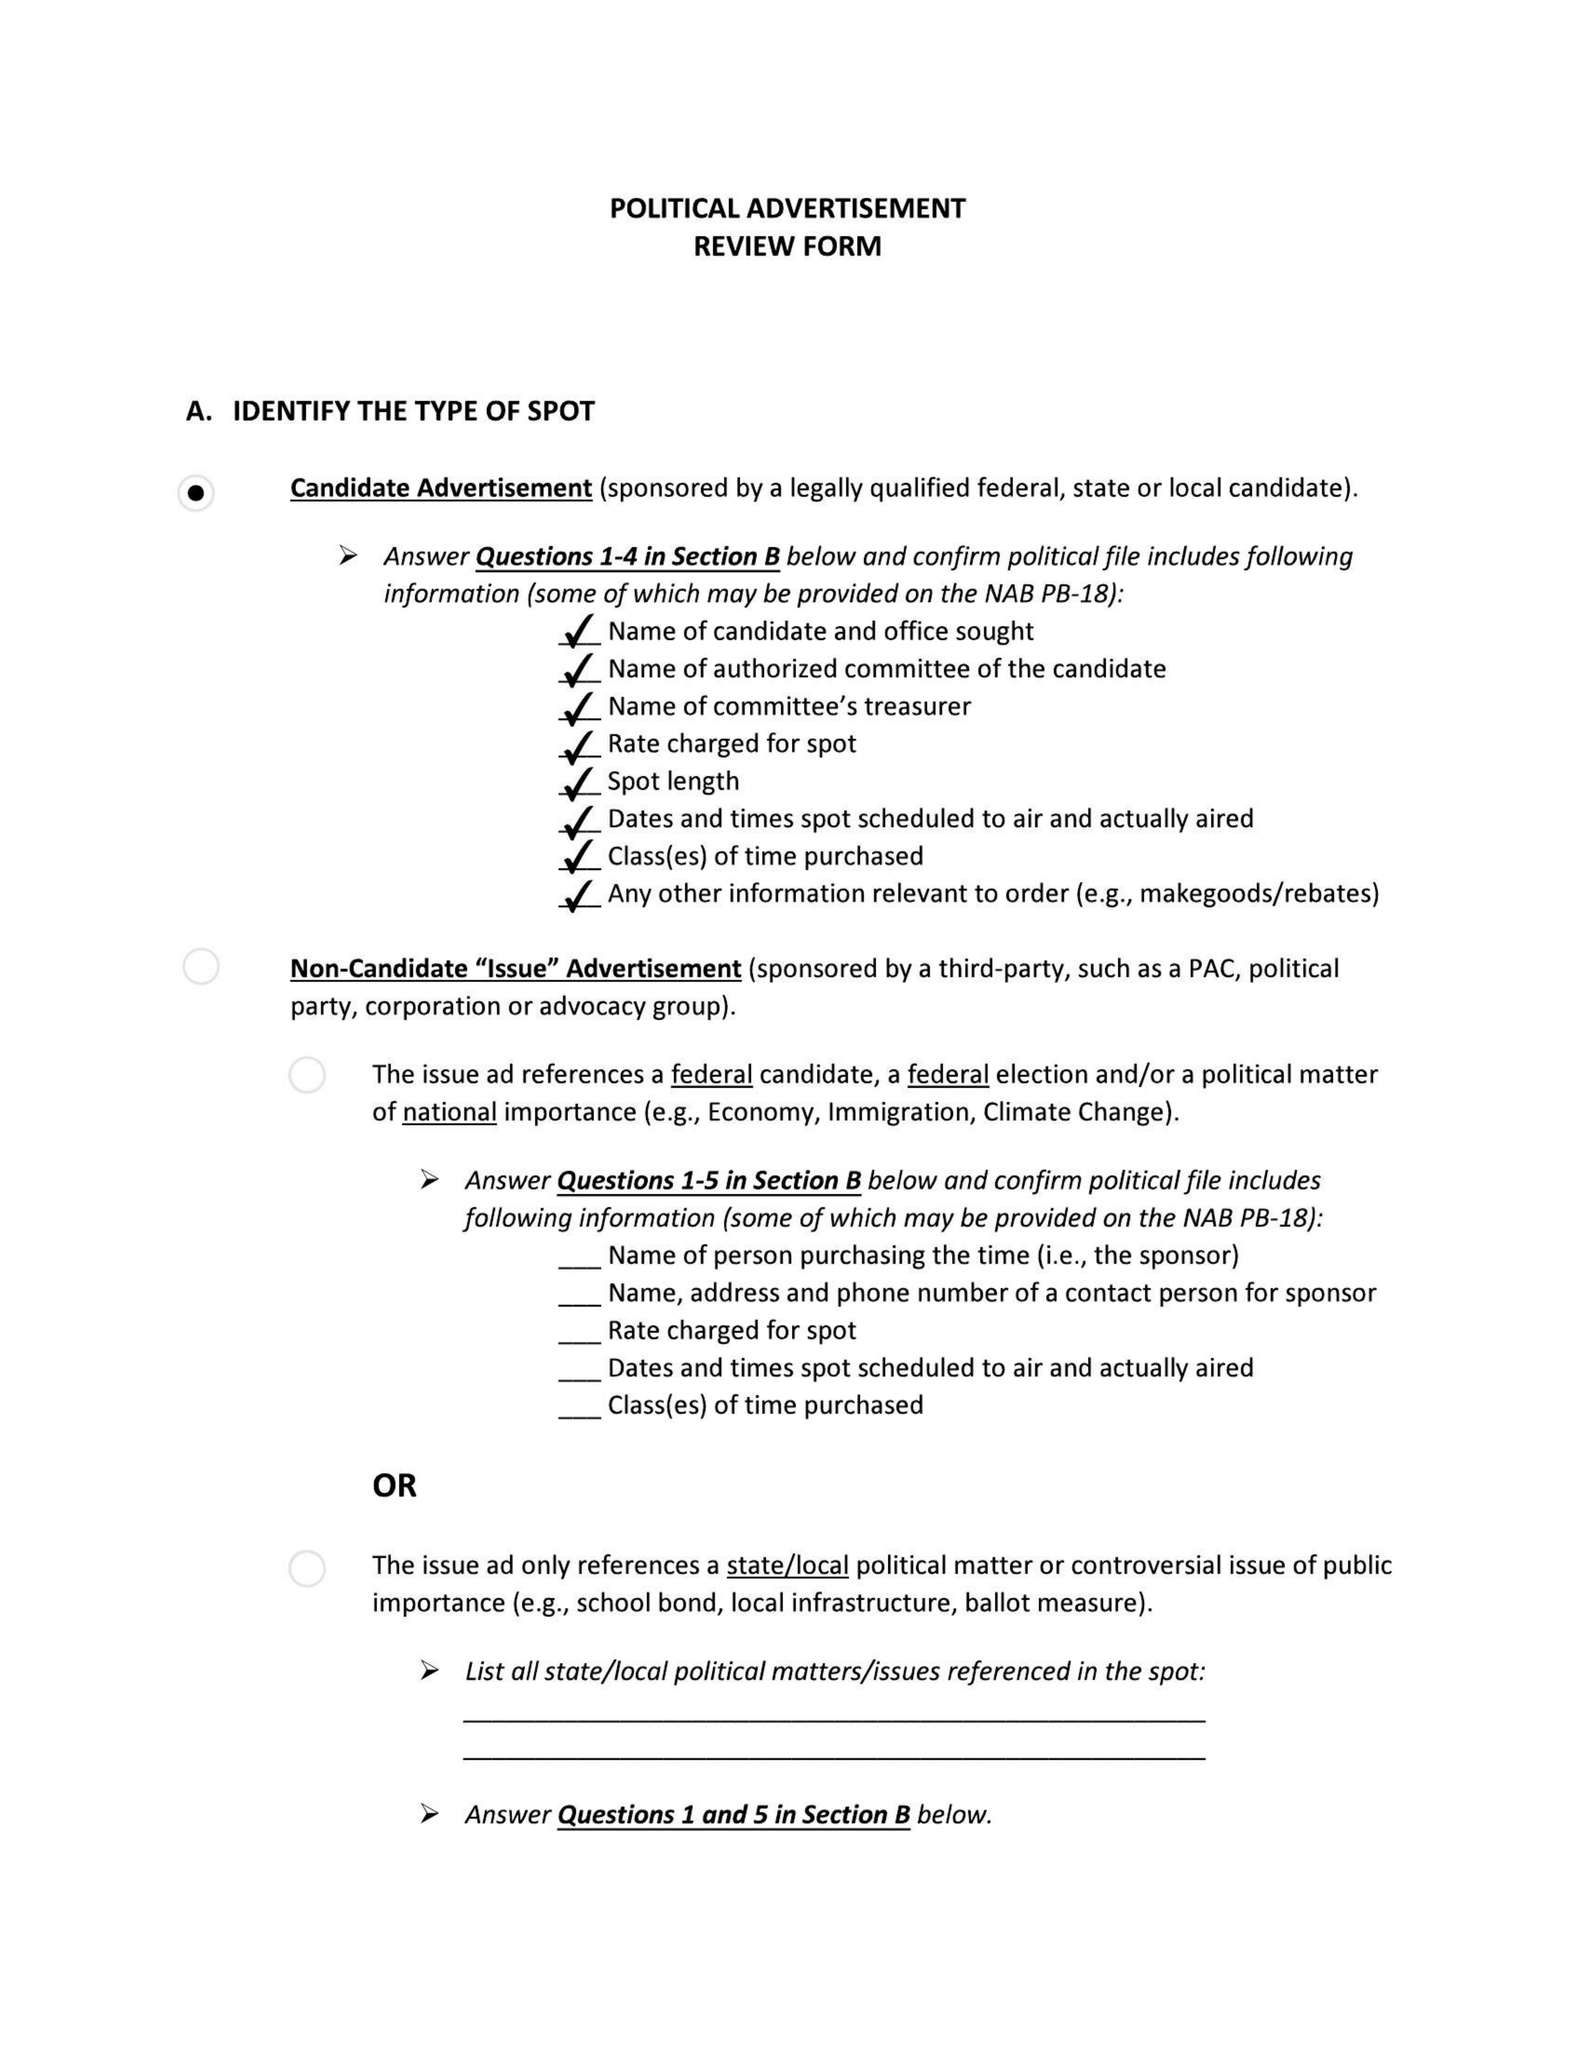What is the value for the flight_to?
Answer the question using a single word or phrase. None 